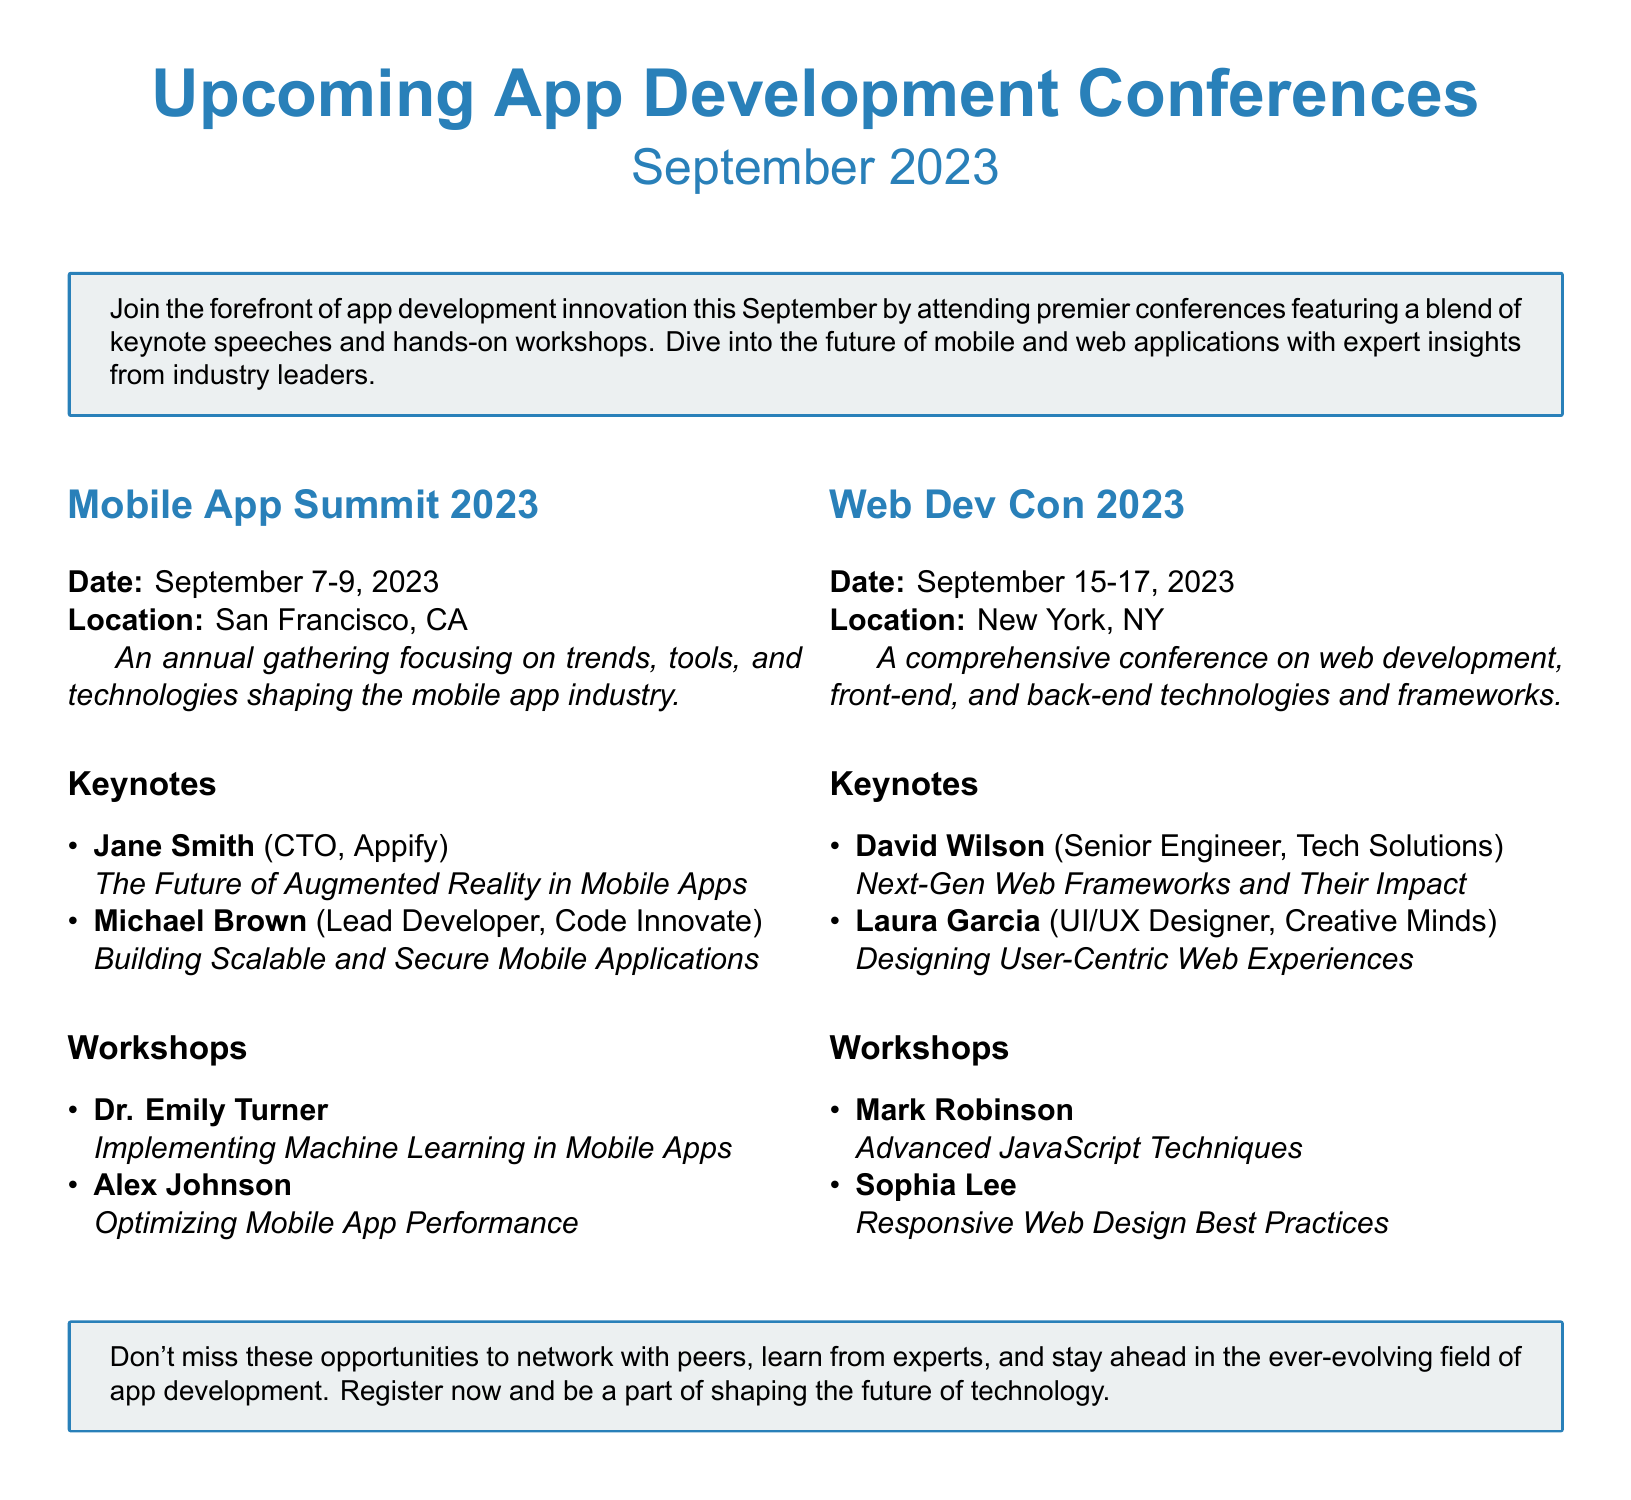What are the dates for the Mobile App Summit 2023? The Mobile App Summit is scheduled from September 7 to September 9, 2023, as stated in the document.
Answer: September 7-9, 2023 Who is the CTO of Appify? Jane Smith is listed as the CTO of Appify in the keynotes section of the conference.
Answer: Jane Smith What is the title of David Wilson's keynote? David Wilson's keynote focuses on "Next-Gen Web Frameworks and Their Impact" according to the document.
Answer: Next-Gen Web Frameworks and Their Impact How many workshops are listed for the Web Dev Con 2023? The document lists two workshops under the Web Dev Con 2023, as indicated in the workshops section.
Answer: Two What location is the Web Dev Con 2023 taking place? The location for the Web Dev Con 2023 is New York, NY, as specified in the event details.
Answer: New York, NY Which speaker is hosting a workshop on machine learning? Dr. Emily Turner is noted for hosting a workshop on implementing machine learning in mobile apps.
Answer: Dr. Emily Turner What is the primary focus of the Mobile App Summit 2023? The Mobile App Summit focuses on trends, tools, and technologies shaping the mobile app industry, as described in the document.
Answer: Trends, tools, and technologies How many keynote speakers are listed for the Mobile App Summit 2023? The document lists two keynote speakers for the Mobile App Summit 2023.
Answer: Two 